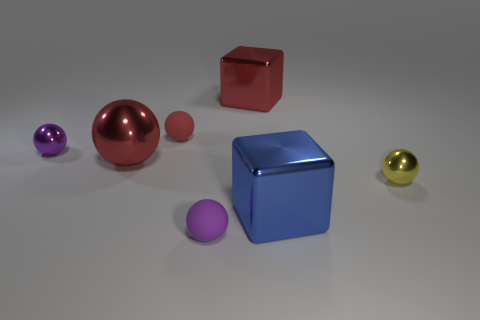What is the material of the other large thing that is the same shape as the large blue metallic object?
Your answer should be compact. Metal. There is a tiny rubber ball behind the large sphere; what is its color?
Offer a very short reply. Red. How big is the yellow object?
Offer a terse response. Small. There is a blue metal object; does it have the same size as the matte sphere that is right of the tiny red object?
Offer a very short reply. No. What color is the large object right of the red thing that is on the right side of the small purple ball in front of the yellow ball?
Make the answer very short. Blue. Is the material of the block in front of the tiny yellow metal object the same as the yellow sphere?
Ensure brevity in your answer.  Yes. What number of other objects are there of the same material as the red block?
Your answer should be compact. 4. There is a red object that is the same size as the purple matte ball; what is its material?
Your response must be concise. Rubber. Is the shape of the small metallic object that is on the left side of the large blue metal block the same as the purple thing in front of the large red shiny ball?
Offer a very short reply. Yes. The purple object that is the same size as the purple metallic ball is what shape?
Offer a terse response. Sphere. 